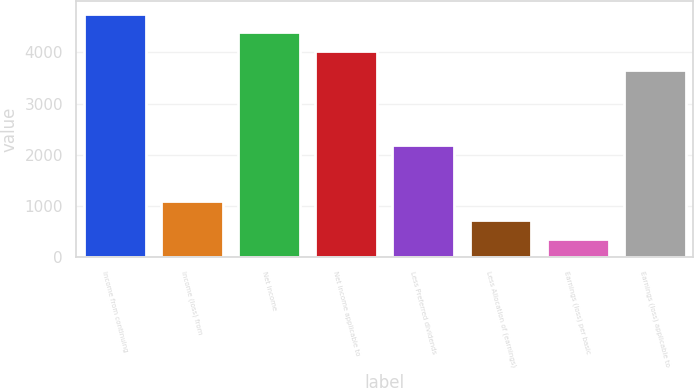Convert chart to OTSL. <chart><loc_0><loc_0><loc_500><loc_500><bar_chart><fcel>Income from continuing<fcel>Income (loss) from<fcel>Net income<fcel>Net income applicable to<fcel>Less Preferred dividends<fcel>Less Allocation of (earnings)<fcel>Earnings (loss) per basic<fcel>Earnings (loss) applicable to<nl><fcel>4752.34<fcel>1097.74<fcel>4386.88<fcel>4021.42<fcel>2194.12<fcel>732.28<fcel>366.82<fcel>3655.96<nl></chart> 